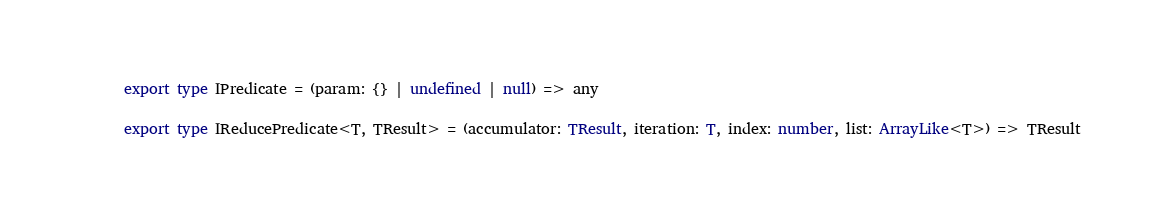Convert code to text. <code><loc_0><loc_0><loc_500><loc_500><_TypeScript_>export type IPredicate = (param: {} | undefined | null) => any

export type IReducePredicate<T, TResult> = (accumulator: TResult, iteration: T, index: number, list: ArrayLike<T>) => TResult
</code> 